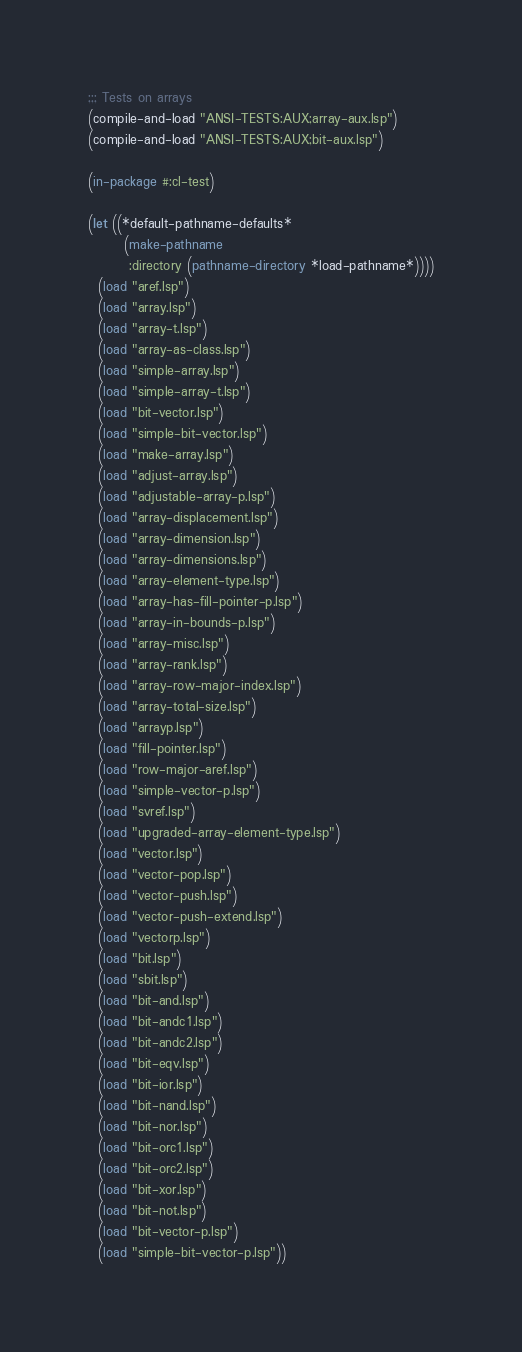Convert code to text. <code><loc_0><loc_0><loc_500><loc_500><_Lisp_>;;; Tests on arrays
(compile-and-load "ANSI-TESTS:AUX;array-aux.lsp")
(compile-and-load "ANSI-TESTS:AUX;bit-aux.lsp")

(in-package #:cl-test)

(let ((*default-pathname-defaults*
       (make-pathname
        :directory (pathname-directory *load-pathname*))))
  (load "aref.lsp")
  (load "array.lsp")
  (load "array-t.lsp")
  (load "array-as-class.lsp")
  (load "simple-array.lsp")
  (load "simple-array-t.lsp")
  (load "bit-vector.lsp")
  (load "simple-bit-vector.lsp")
  (load "make-array.lsp")
  (load "adjust-array.lsp")
  (load "adjustable-array-p.lsp")
  (load "array-displacement.lsp")
  (load "array-dimension.lsp")
  (load "array-dimensions.lsp")
  (load "array-element-type.lsp")
  (load "array-has-fill-pointer-p.lsp")
  (load "array-in-bounds-p.lsp")
  (load "array-misc.lsp")
  (load "array-rank.lsp")
  (load "array-row-major-index.lsp")
  (load "array-total-size.lsp")
  (load "arrayp.lsp")
  (load "fill-pointer.lsp")
  (load "row-major-aref.lsp")
  (load "simple-vector-p.lsp")
  (load "svref.lsp")
  (load "upgraded-array-element-type.lsp")
  (load "vector.lsp")
  (load "vector-pop.lsp")
  (load "vector-push.lsp")
  (load "vector-push-extend.lsp")
  (load "vectorp.lsp")
  (load "bit.lsp")
  (load "sbit.lsp")
  (load "bit-and.lsp")
  (load "bit-andc1.lsp")
  (load "bit-andc2.lsp")
  (load "bit-eqv.lsp")
  (load "bit-ior.lsp")
  (load "bit-nand.lsp")
  (load "bit-nor.lsp")
  (load "bit-orc1.lsp")
  (load "bit-orc2.lsp")
  (load "bit-xor.lsp")
  (load "bit-not.lsp")
  (load "bit-vector-p.lsp")
  (load "simple-bit-vector-p.lsp"))
</code> 